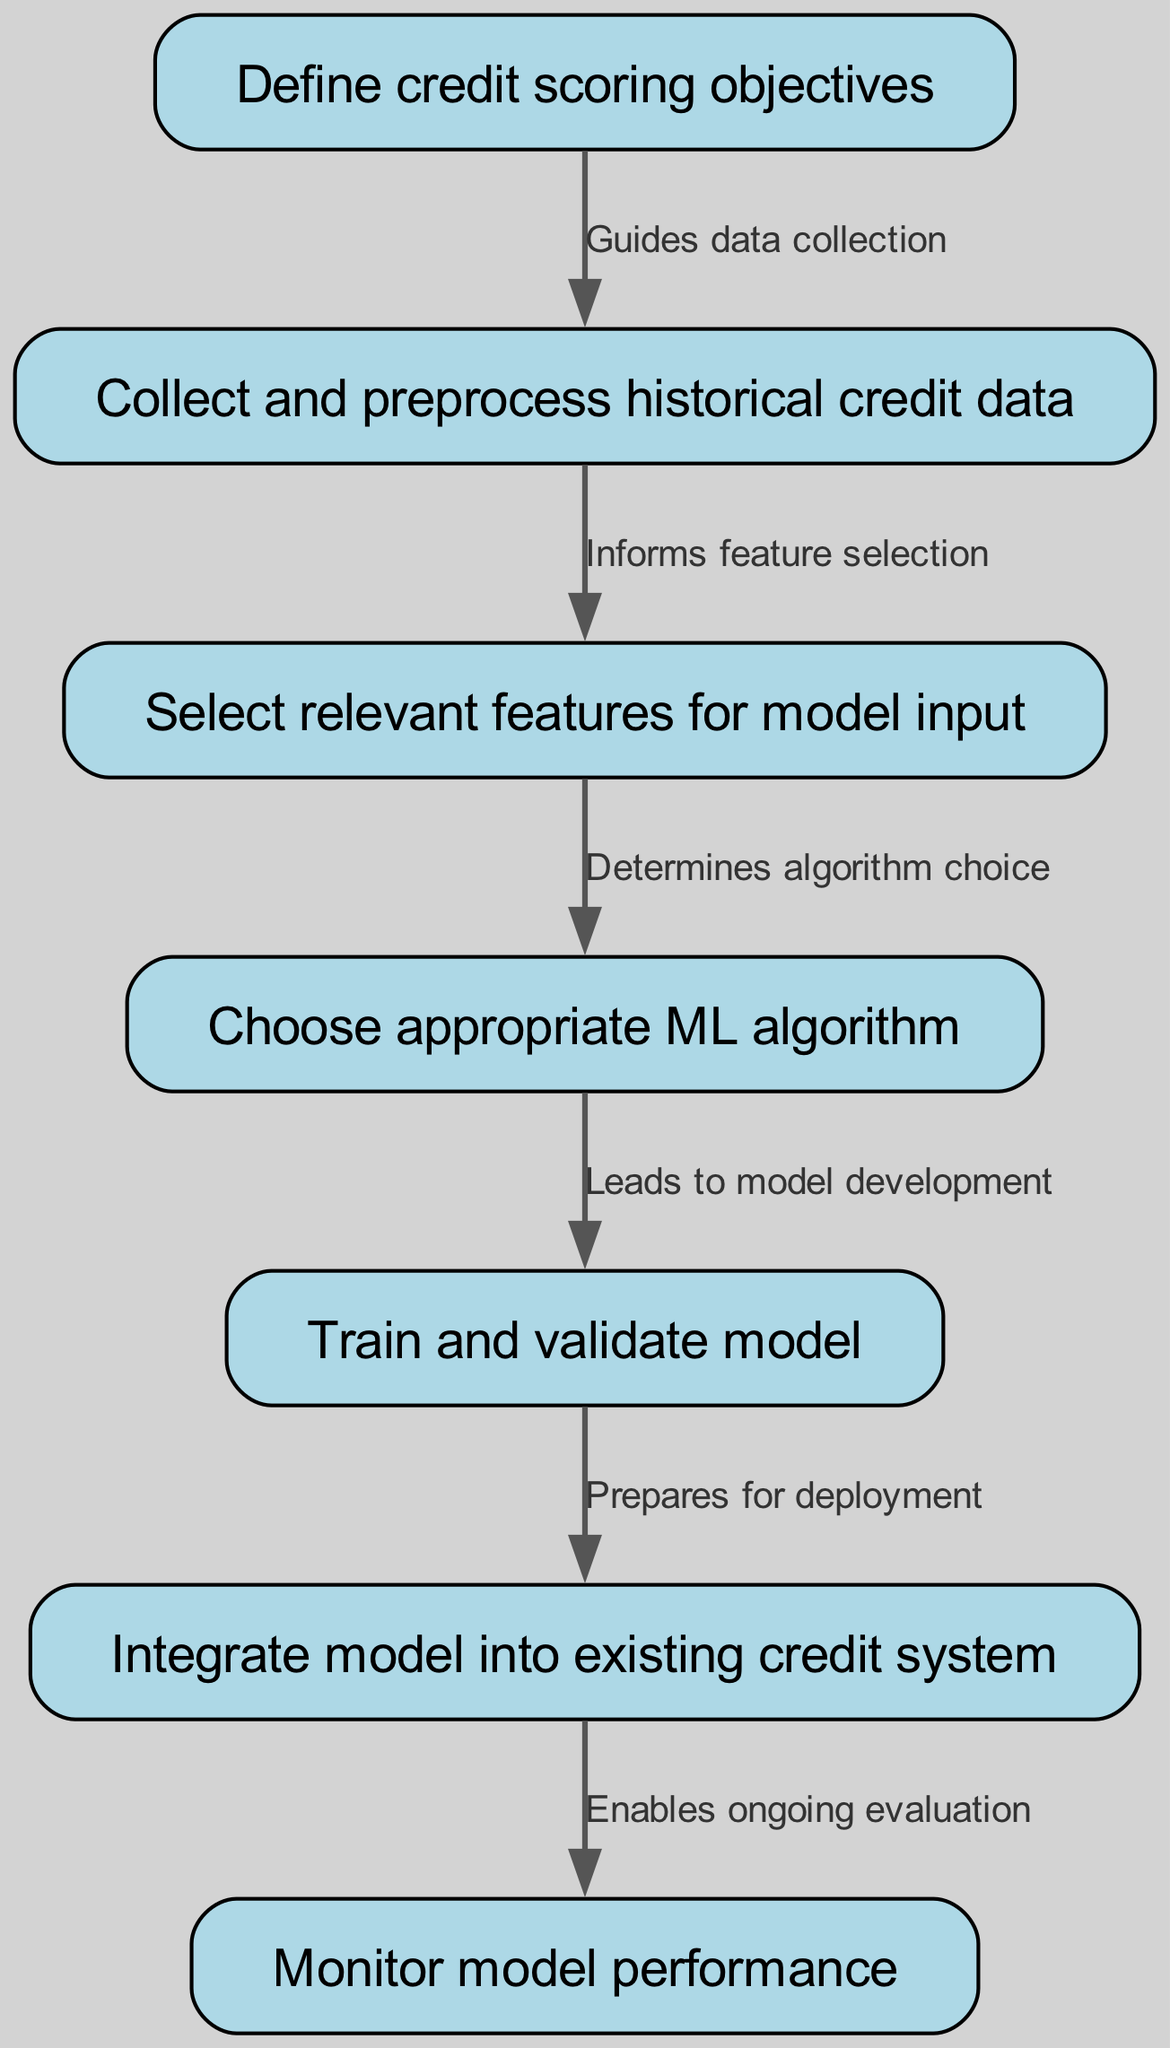What is the first step in the credit scoring implementation? The flow chart indicates that the first step is to "Define credit scoring objectives," which guides all subsequent actions.
Answer: Define credit scoring objectives How many steps are there in the implementation process? By counting the nodes in the diagram, there are a total of seven steps in the implementation process.
Answer: Seven Which step comes after "Train and validate model"? Looking at the flow of the diagram, "Integrate model into existing credit system" follows after "Train and validate model."
Answer: Integrate model into existing credit system What does "Collect and preprocess historical credit data" inform? The edge connecting the nodes shows that "Collect and preprocess historical credit data" informs the next step, which is "Select relevant features for model input."
Answer: Select relevant features for model input How many edges are present in the diagram? By counting the connections between the nodes, there are a total of six edges in this implementation flow chart.
Answer: Six Which stage leads to model development? The diagram indicates that the choice of algorithm, represented by "Choose appropriate ML algorithm," directly leads to model development in the subsequent step.
Answer: Choose appropriate ML algorithm What enables ongoing evaluation according to the diagram? The final edge in the diagram states that the integration of the model into the system, shown as "Integrate model into existing credit system," enables ongoing evaluation in the next step.
Answer: Integrate model into existing credit system What is the relationship between "Select relevant features for model input" and "Choose appropriate ML algorithm"? The arrow from "Select relevant features for model input" to "Choose appropriate ML algorithm" signifies that the selected features directly determine or influence the algorithm choice.
Answer: Determines algorithm choice What step prepares the model for deployment? The flow indicates that the "Train and validate model" step prepares the model for deployment as shown in the connection to the “Integrate model into existing credit system.”
Answer: Train and validate model 